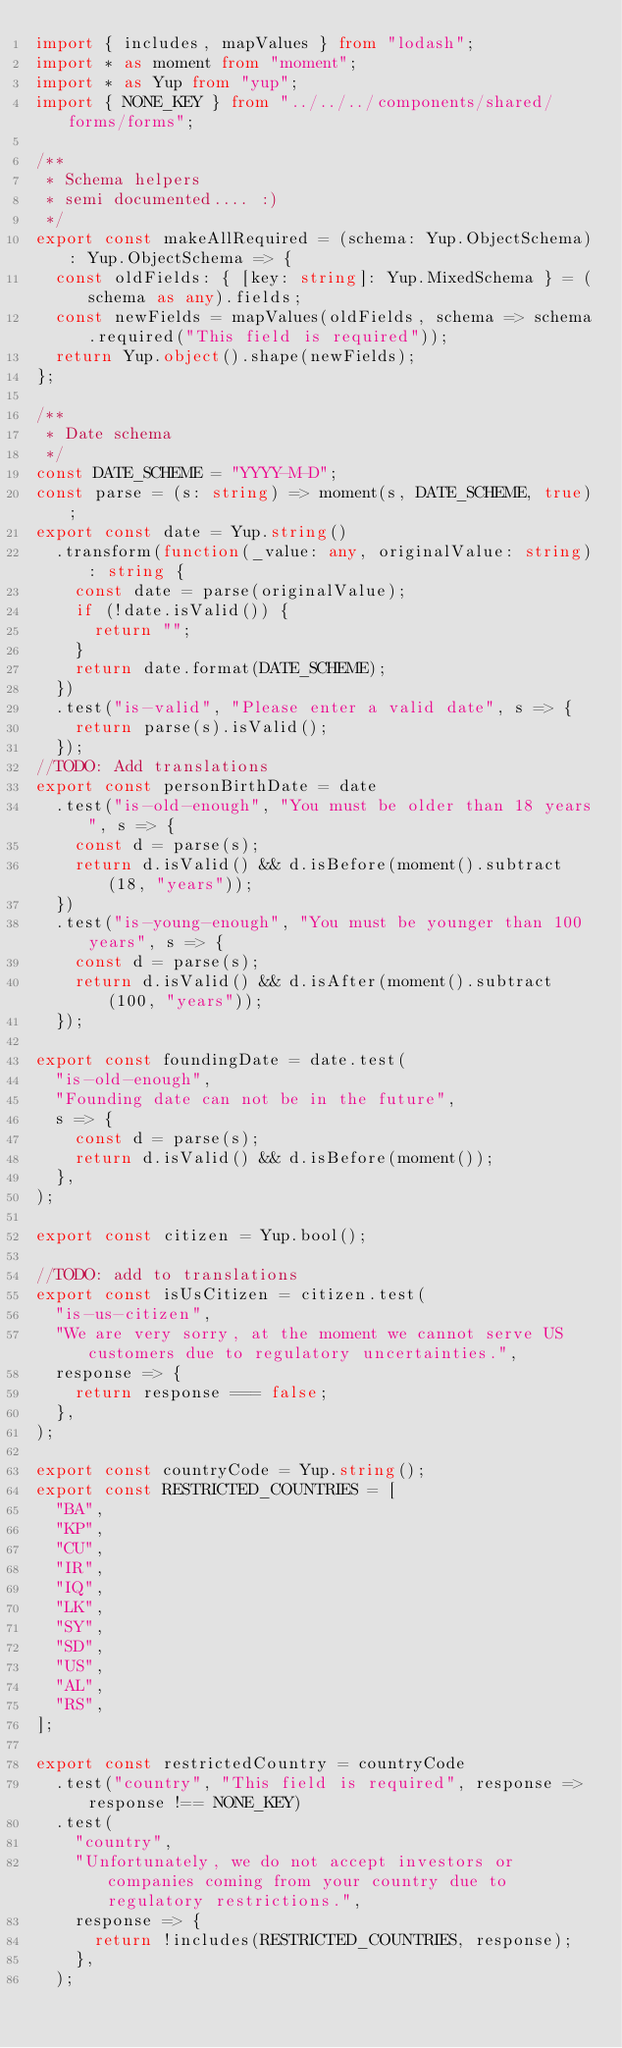<code> <loc_0><loc_0><loc_500><loc_500><_TypeScript_>import { includes, mapValues } from "lodash";
import * as moment from "moment";
import * as Yup from "yup";
import { NONE_KEY } from "../../../components/shared/forms/forms";

/**
 * Schema helpers
 * semi documented.... :)
 */
export const makeAllRequired = (schema: Yup.ObjectSchema): Yup.ObjectSchema => {
  const oldFields: { [key: string]: Yup.MixedSchema } = (schema as any).fields;
  const newFields = mapValues(oldFields, schema => schema.required("This field is required"));
  return Yup.object().shape(newFields);
};

/**
 * Date schema
 */
const DATE_SCHEME = "YYYY-M-D";
const parse = (s: string) => moment(s, DATE_SCHEME, true);
export const date = Yup.string()
  .transform(function(_value: any, originalValue: string): string {
    const date = parse(originalValue);
    if (!date.isValid()) {
      return "";
    }
    return date.format(DATE_SCHEME);
  })
  .test("is-valid", "Please enter a valid date", s => {
    return parse(s).isValid();
  });
//TODO: Add translations
export const personBirthDate = date
  .test("is-old-enough", "You must be older than 18 years", s => {
    const d = parse(s);
    return d.isValid() && d.isBefore(moment().subtract(18, "years"));
  })
  .test("is-young-enough", "You must be younger than 100 years", s => {
    const d = parse(s);
    return d.isValid() && d.isAfter(moment().subtract(100, "years"));
  });

export const foundingDate = date.test(
  "is-old-enough",
  "Founding date can not be in the future",
  s => {
    const d = parse(s);
    return d.isValid() && d.isBefore(moment());
  },
);

export const citizen = Yup.bool();

//TODO: add to translations
export const isUsCitizen = citizen.test(
  "is-us-citizen",
  "We are very sorry, at the moment we cannot serve US customers due to regulatory uncertainties.",
  response => {
    return response === false;
  },
);

export const countryCode = Yup.string();
export const RESTRICTED_COUNTRIES = [
  "BA",
  "KP",
  "CU",
  "IR",
  "IQ",
  "LK",
  "SY",
  "SD",
  "US",
  "AL",
  "RS",
];

export const restrictedCountry = countryCode
  .test("country", "This field is required", response => response !== NONE_KEY)
  .test(
    "country",
    "Unfortunately, we do not accept investors or companies coming from your country due to regulatory restrictions.",
    response => {
      return !includes(RESTRICTED_COUNTRIES, response);
    },
  );
</code> 